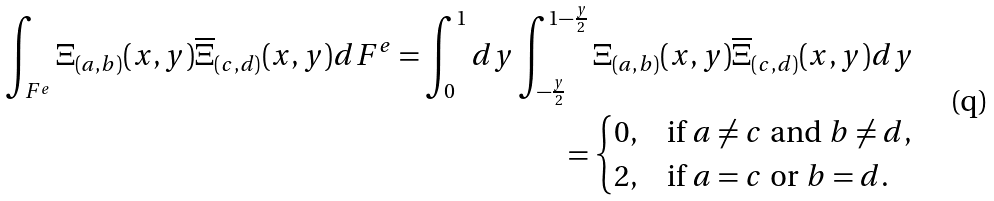<formula> <loc_0><loc_0><loc_500><loc_500>\int _ { F ^ { e } } \Xi _ { ( a , b ) } ( x , y ) \overline { \Xi } _ { ( c , d ) } ( x , y ) d F ^ { e } = \int _ { 0 } ^ { 1 } d y \int _ { - \frac { y } { 2 } } ^ { 1 - \frac { y } { 2 } } \Xi _ { ( a , b ) } ( x , y ) \overline { \Xi } _ { ( c , d ) } ( x , y ) d y \\ = \begin{cases} 0 , & \text {if $a\neq c$ and $b\neq d$,} \\ 2 , & \text {if $a=c$ or $b=d$.} \end{cases}</formula> 